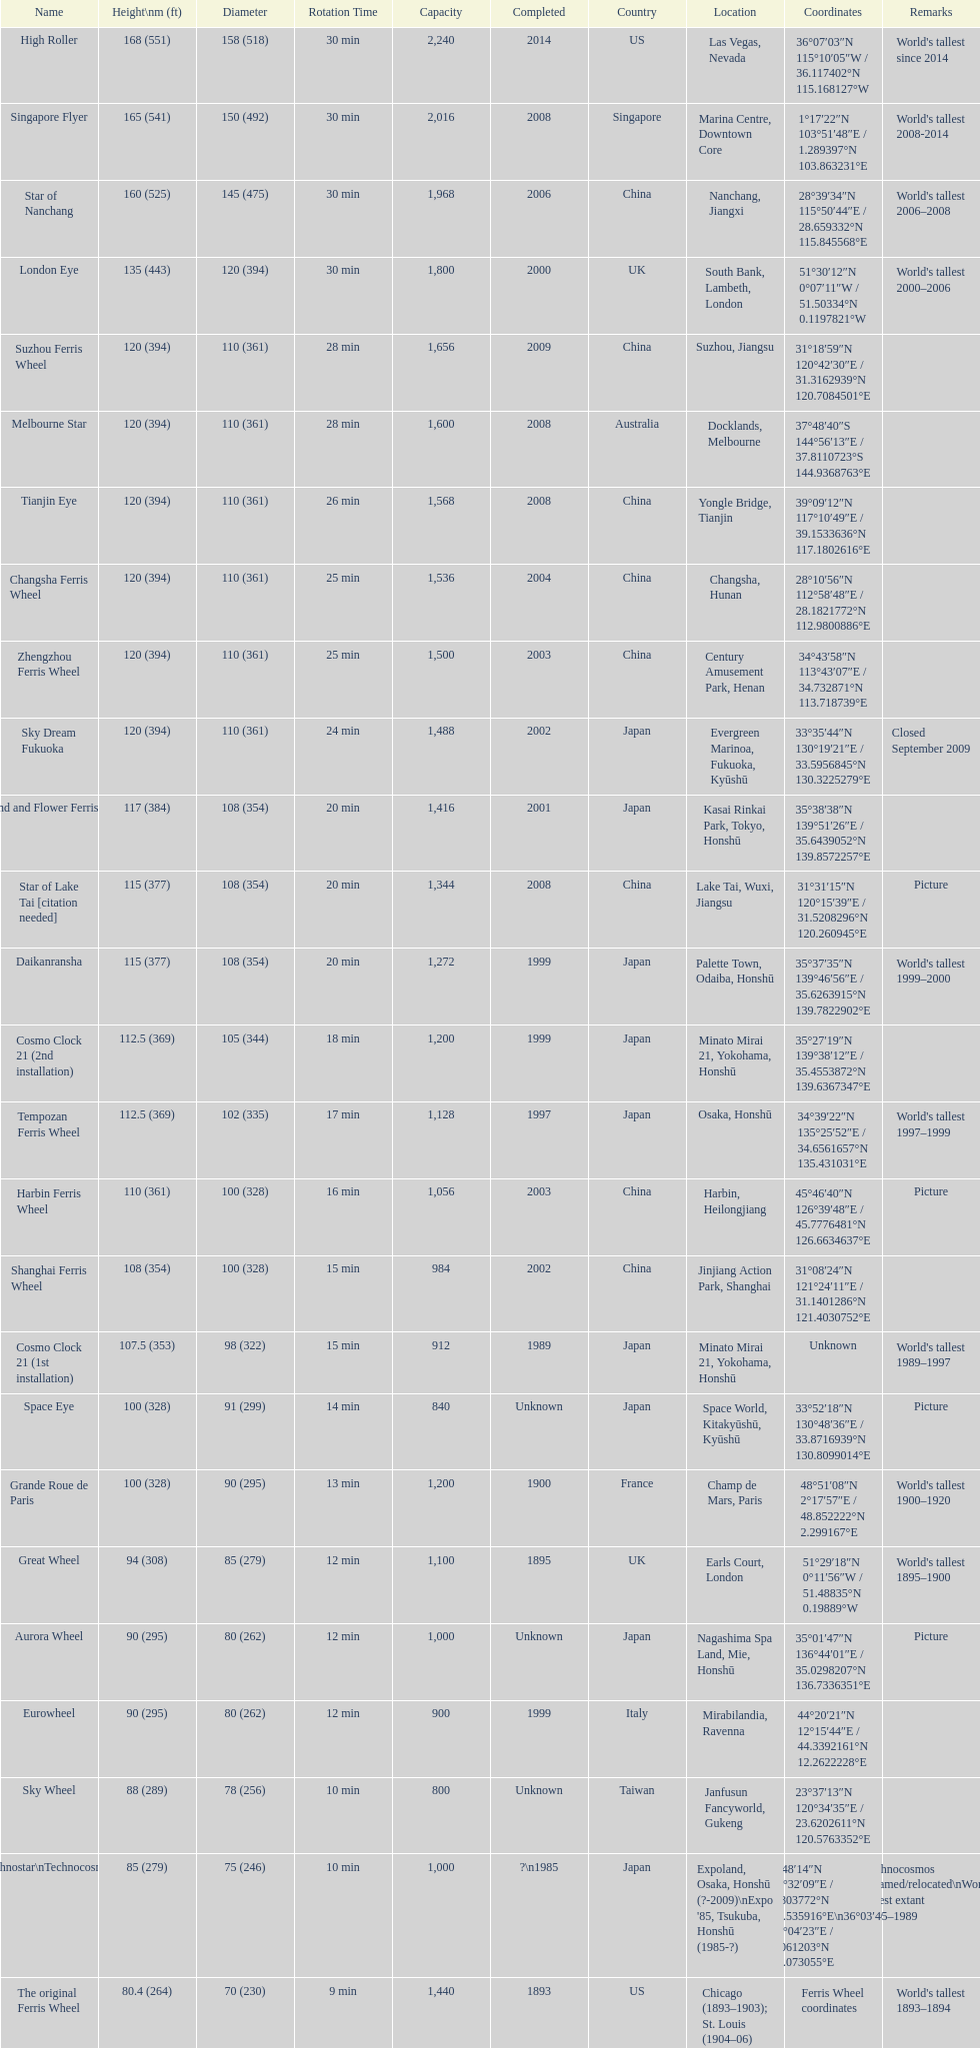Which country had the most roller coasters over 80 feet in height in 2008? China. 